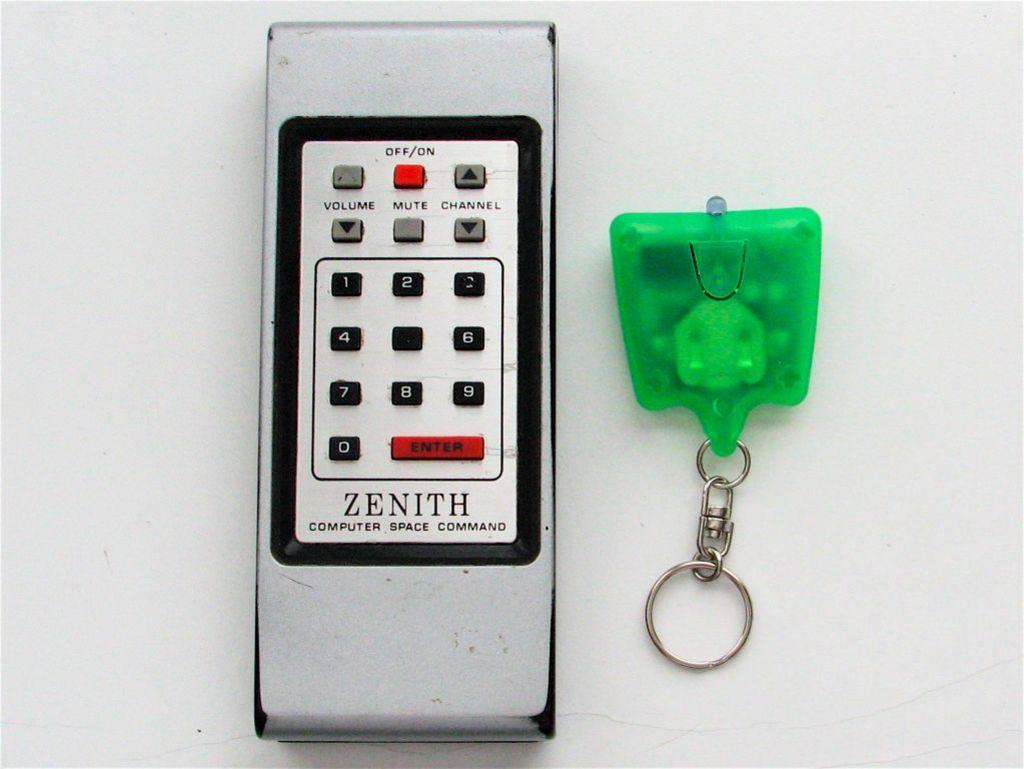<image>
Write a terse but informative summary of the picture. A silver remote says Zenith Computer Space Command and is next to a green key chain. 